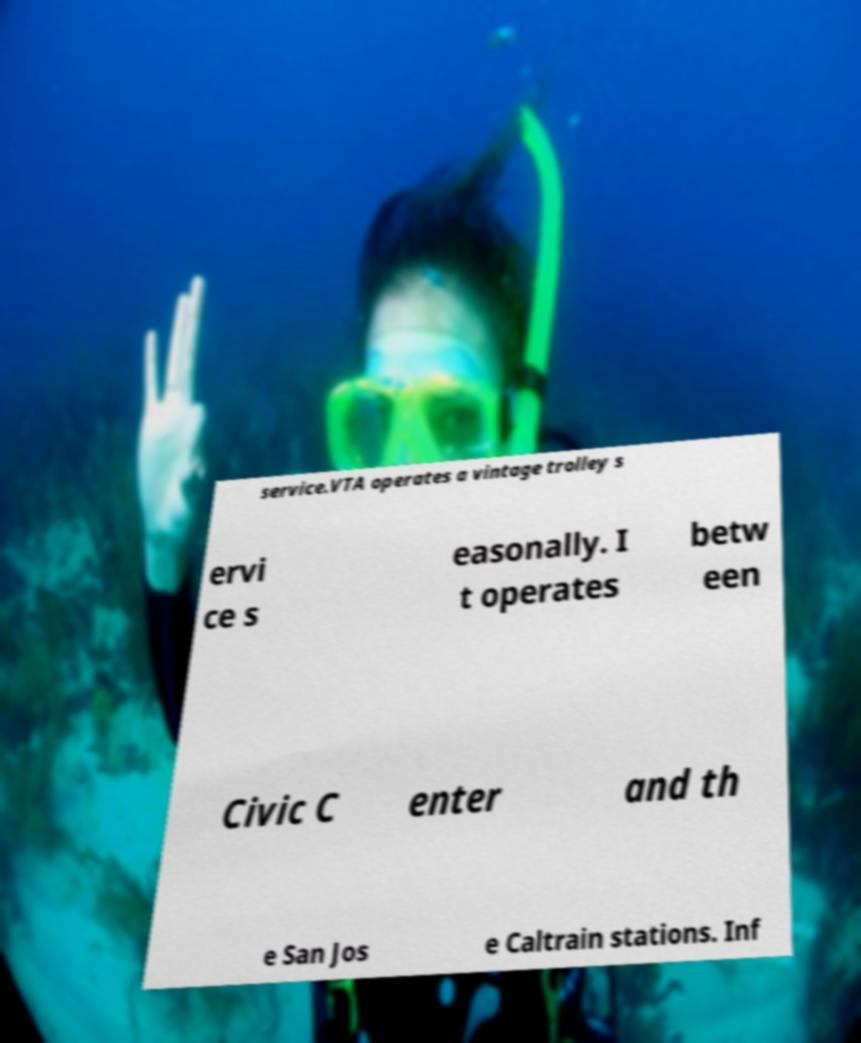Could you extract and type out the text from this image? service.VTA operates a vintage trolley s ervi ce s easonally. I t operates betw een Civic C enter and th e San Jos e Caltrain stations. Inf 